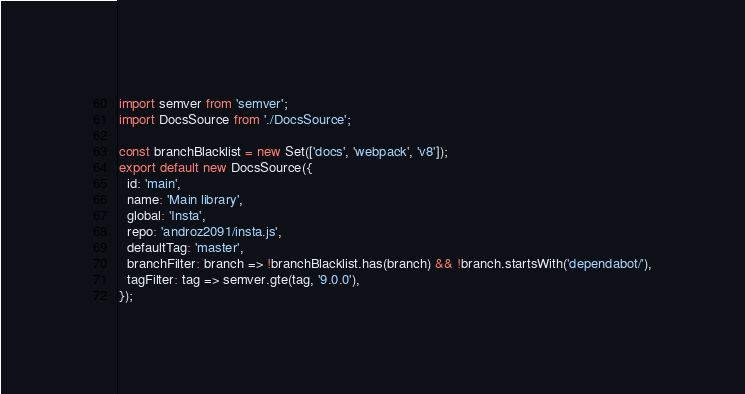<code> <loc_0><loc_0><loc_500><loc_500><_JavaScript_>import semver from 'semver';
import DocsSource from './DocsSource';

const branchBlacklist = new Set(['docs', 'webpack', 'v8']);
export default new DocsSource({
  id: 'main',
  name: 'Main library',
  global: 'Insta',
  repo: 'androz2091/insta.js',
  defaultTag: 'master',
  branchFilter: branch => !branchBlacklist.has(branch) && !branch.startsWith('dependabot/'),
  tagFilter: tag => semver.gte(tag, '9.0.0'),
});
</code> 